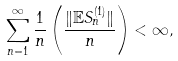Convert formula to latex. <formula><loc_0><loc_0><loc_500><loc_500>\sum _ { n = 1 } ^ { \infty } \frac { 1 } { n } \left ( \frac { \| \mathbb { E } S _ { n } ^ { ( 1 ) } \| } { n } \right ) < \infty ,</formula> 